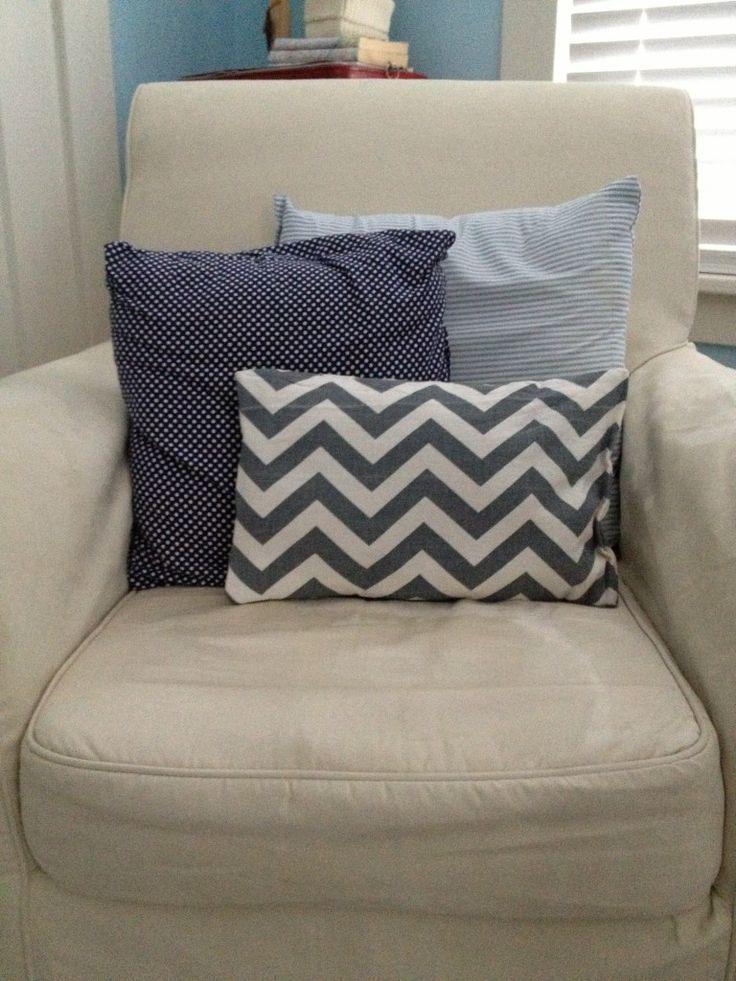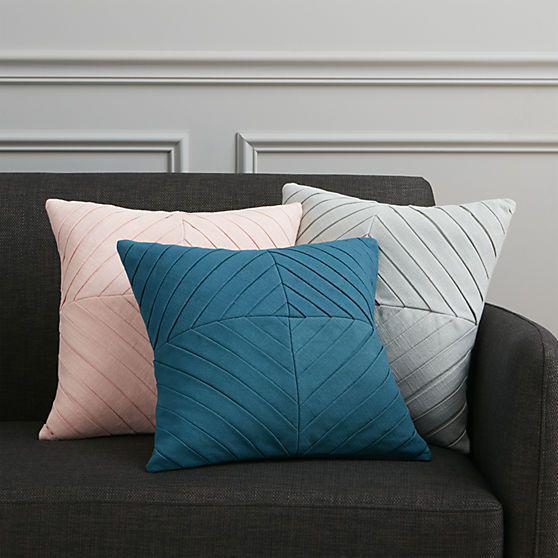The first image is the image on the left, the second image is the image on the right. Given the left and right images, does the statement "The image to the left is clearly a bed." hold true? Answer yes or no. No. The first image is the image on the left, the second image is the image on the right. Considering the images on both sides, is "An image shows a bed with a blue bedding component and two square non-white pillows facing forward." valid? Answer yes or no. No. 